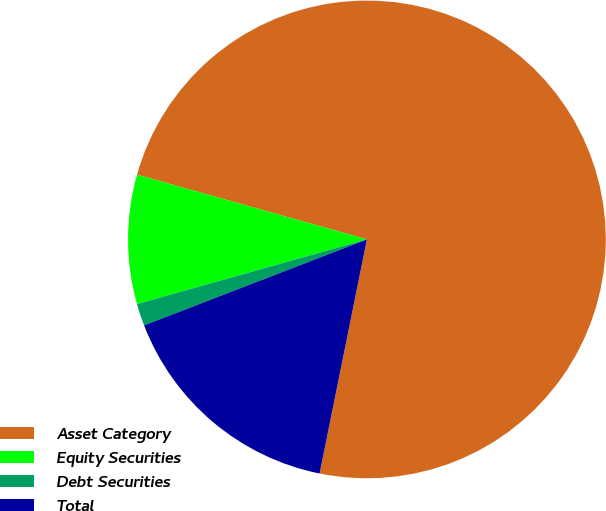Convert chart. <chart><loc_0><loc_0><loc_500><loc_500><pie_chart><fcel>Asset Category<fcel>Equity Securities<fcel>Debt Securities<fcel>Total<nl><fcel>73.8%<fcel>8.73%<fcel>1.5%<fcel>15.96%<nl></chart> 